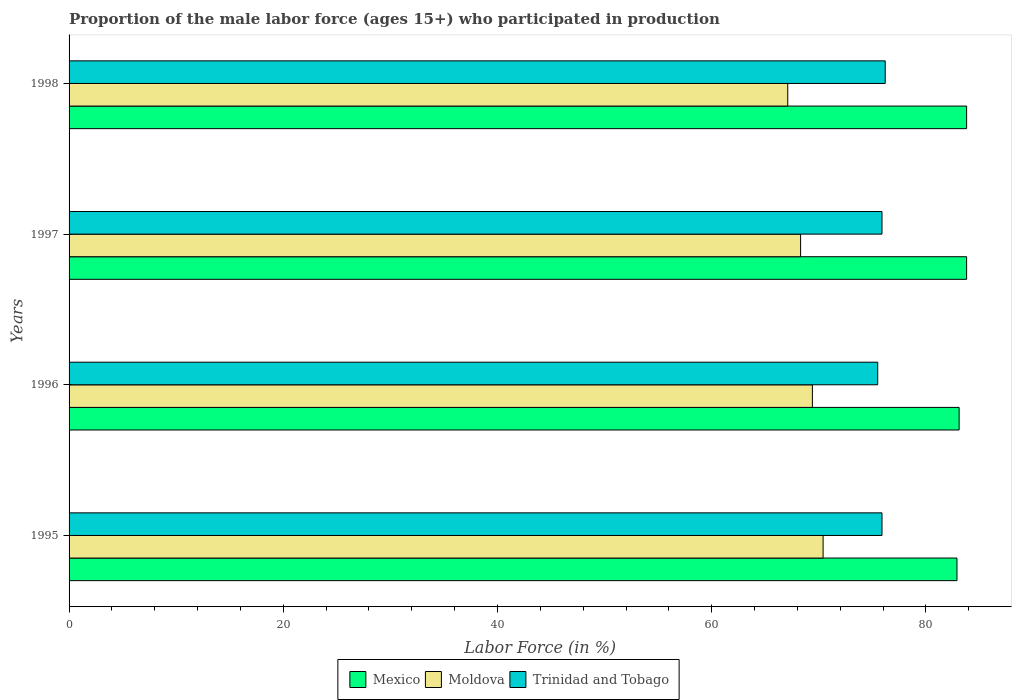How many different coloured bars are there?
Your answer should be compact. 3. Are the number of bars per tick equal to the number of legend labels?
Give a very brief answer. Yes. Are the number of bars on each tick of the Y-axis equal?
Your answer should be compact. Yes. How many bars are there on the 2nd tick from the bottom?
Offer a very short reply. 3. What is the label of the 4th group of bars from the top?
Offer a terse response. 1995. What is the proportion of the male labor force who participated in production in Mexico in 1997?
Give a very brief answer. 83.8. Across all years, what is the maximum proportion of the male labor force who participated in production in Mexico?
Offer a terse response. 83.8. Across all years, what is the minimum proportion of the male labor force who participated in production in Mexico?
Provide a short and direct response. 82.9. In which year was the proportion of the male labor force who participated in production in Moldova maximum?
Provide a short and direct response. 1995. What is the total proportion of the male labor force who participated in production in Mexico in the graph?
Your response must be concise. 333.6. What is the difference between the proportion of the male labor force who participated in production in Moldova in 1997 and that in 1998?
Give a very brief answer. 1.2. What is the difference between the proportion of the male labor force who participated in production in Mexico in 1995 and the proportion of the male labor force who participated in production in Moldova in 1998?
Ensure brevity in your answer.  15.8. What is the average proportion of the male labor force who participated in production in Trinidad and Tobago per year?
Ensure brevity in your answer.  75.88. In the year 1995, what is the difference between the proportion of the male labor force who participated in production in Mexico and proportion of the male labor force who participated in production in Moldova?
Keep it short and to the point. 12.5. In how many years, is the proportion of the male labor force who participated in production in Trinidad and Tobago greater than 64 %?
Give a very brief answer. 4. Is the difference between the proportion of the male labor force who participated in production in Mexico in 1996 and 1998 greater than the difference between the proportion of the male labor force who participated in production in Moldova in 1996 and 1998?
Your response must be concise. No. What is the difference between the highest and the second highest proportion of the male labor force who participated in production in Moldova?
Make the answer very short. 1. What is the difference between the highest and the lowest proportion of the male labor force who participated in production in Moldova?
Your answer should be very brief. 3.3. Is the sum of the proportion of the male labor force who participated in production in Moldova in 1995 and 1998 greater than the maximum proportion of the male labor force who participated in production in Mexico across all years?
Give a very brief answer. Yes. What does the 2nd bar from the top in 1998 represents?
Your answer should be very brief. Moldova. What does the 2nd bar from the bottom in 1998 represents?
Offer a terse response. Moldova. Is it the case that in every year, the sum of the proportion of the male labor force who participated in production in Moldova and proportion of the male labor force who participated in production in Mexico is greater than the proportion of the male labor force who participated in production in Trinidad and Tobago?
Your answer should be very brief. Yes. How many bars are there?
Keep it short and to the point. 12. How many years are there in the graph?
Offer a very short reply. 4. Does the graph contain any zero values?
Your response must be concise. No. Does the graph contain grids?
Offer a terse response. No. How many legend labels are there?
Your answer should be very brief. 3. How are the legend labels stacked?
Keep it short and to the point. Horizontal. What is the title of the graph?
Ensure brevity in your answer.  Proportion of the male labor force (ages 15+) who participated in production. What is the label or title of the Y-axis?
Give a very brief answer. Years. What is the Labor Force (in %) of Mexico in 1995?
Provide a short and direct response. 82.9. What is the Labor Force (in %) in Moldova in 1995?
Provide a succinct answer. 70.4. What is the Labor Force (in %) in Trinidad and Tobago in 1995?
Offer a terse response. 75.9. What is the Labor Force (in %) in Mexico in 1996?
Provide a succinct answer. 83.1. What is the Labor Force (in %) of Moldova in 1996?
Your answer should be compact. 69.4. What is the Labor Force (in %) of Trinidad and Tobago in 1996?
Your response must be concise. 75.5. What is the Labor Force (in %) of Mexico in 1997?
Provide a short and direct response. 83.8. What is the Labor Force (in %) of Moldova in 1997?
Offer a very short reply. 68.3. What is the Labor Force (in %) of Trinidad and Tobago in 1997?
Ensure brevity in your answer.  75.9. What is the Labor Force (in %) of Mexico in 1998?
Give a very brief answer. 83.8. What is the Labor Force (in %) of Moldova in 1998?
Provide a short and direct response. 67.1. What is the Labor Force (in %) in Trinidad and Tobago in 1998?
Provide a short and direct response. 76.2. Across all years, what is the maximum Labor Force (in %) in Mexico?
Your answer should be compact. 83.8. Across all years, what is the maximum Labor Force (in %) in Moldova?
Offer a terse response. 70.4. Across all years, what is the maximum Labor Force (in %) in Trinidad and Tobago?
Your answer should be compact. 76.2. Across all years, what is the minimum Labor Force (in %) of Mexico?
Keep it short and to the point. 82.9. Across all years, what is the minimum Labor Force (in %) in Moldova?
Give a very brief answer. 67.1. Across all years, what is the minimum Labor Force (in %) of Trinidad and Tobago?
Your answer should be very brief. 75.5. What is the total Labor Force (in %) in Mexico in the graph?
Offer a very short reply. 333.6. What is the total Labor Force (in %) of Moldova in the graph?
Your answer should be compact. 275.2. What is the total Labor Force (in %) of Trinidad and Tobago in the graph?
Give a very brief answer. 303.5. What is the difference between the Labor Force (in %) of Mexico in 1995 and that in 1996?
Keep it short and to the point. -0.2. What is the difference between the Labor Force (in %) in Moldova in 1995 and that in 1996?
Your answer should be compact. 1. What is the difference between the Labor Force (in %) of Trinidad and Tobago in 1995 and that in 1997?
Ensure brevity in your answer.  0. What is the difference between the Labor Force (in %) of Mexico in 1995 and that in 1998?
Ensure brevity in your answer.  -0.9. What is the difference between the Labor Force (in %) in Moldova in 1995 and that in 1998?
Keep it short and to the point. 3.3. What is the difference between the Labor Force (in %) of Mexico in 1996 and that in 1998?
Ensure brevity in your answer.  -0.7. What is the difference between the Labor Force (in %) in Moldova in 1995 and the Labor Force (in %) in Trinidad and Tobago in 1996?
Provide a short and direct response. -5.1. What is the difference between the Labor Force (in %) of Mexico in 1995 and the Labor Force (in %) of Moldova in 1997?
Your response must be concise. 14.6. What is the difference between the Labor Force (in %) in Mexico in 1995 and the Labor Force (in %) in Trinidad and Tobago in 1998?
Provide a short and direct response. 6.7. What is the difference between the Labor Force (in %) of Moldova in 1995 and the Labor Force (in %) of Trinidad and Tobago in 1998?
Offer a very short reply. -5.8. What is the difference between the Labor Force (in %) of Mexico in 1996 and the Labor Force (in %) of Moldova in 1997?
Ensure brevity in your answer.  14.8. What is the difference between the Labor Force (in %) of Moldova in 1996 and the Labor Force (in %) of Trinidad and Tobago in 1997?
Your answer should be compact. -6.5. What is the difference between the Labor Force (in %) in Mexico in 1996 and the Labor Force (in %) in Trinidad and Tobago in 1998?
Ensure brevity in your answer.  6.9. What is the difference between the Labor Force (in %) in Mexico in 1997 and the Labor Force (in %) in Moldova in 1998?
Your answer should be very brief. 16.7. What is the difference between the Labor Force (in %) in Mexico in 1997 and the Labor Force (in %) in Trinidad and Tobago in 1998?
Offer a terse response. 7.6. What is the average Labor Force (in %) of Mexico per year?
Make the answer very short. 83.4. What is the average Labor Force (in %) of Moldova per year?
Offer a terse response. 68.8. What is the average Labor Force (in %) of Trinidad and Tobago per year?
Provide a short and direct response. 75.88. In the year 1995, what is the difference between the Labor Force (in %) of Mexico and Labor Force (in %) of Moldova?
Provide a short and direct response. 12.5. In the year 1996, what is the difference between the Labor Force (in %) of Mexico and Labor Force (in %) of Moldova?
Provide a short and direct response. 13.7. In the year 1996, what is the difference between the Labor Force (in %) of Moldova and Labor Force (in %) of Trinidad and Tobago?
Make the answer very short. -6.1. In the year 1997, what is the difference between the Labor Force (in %) of Mexico and Labor Force (in %) of Moldova?
Provide a succinct answer. 15.5. In the year 1997, what is the difference between the Labor Force (in %) of Moldova and Labor Force (in %) of Trinidad and Tobago?
Your answer should be compact. -7.6. In the year 1998, what is the difference between the Labor Force (in %) of Mexico and Labor Force (in %) of Moldova?
Your answer should be compact. 16.7. In the year 1998, what is the difference between the Labor Force (in %) of Mexico and Labor Force (in %) of Trinidad and Tobago?
Keep it short and to the point. 7.6. What is the ratio of the Labor Force (in %) in Mexico in 1995 to that in 1996?
Your answer should be very brief. 1. What is the ratio of the Labor Force (in %) of Moldova in 1995 to that in 1996?
Offer a very short reply. 1.01. What is the ratio of the Labor Force (in %) of Trinidad and Tobago in 1995 to that in 1996?
Your answer should be compact. 1.01. What is the ratio of the Labor Force (in %) of Mexico in 1995 to that in 1997?
Your answer should be compact. 0.99. What is the ratio of the Labor Force (in %) in Moldova in 1995 to that in 1997?
Keep it short and to the point. 1.03. What is the ratio of the Labor Force (in %) in Mexico in 1995 to that in 1998?
Provide a succinct answer. 0.99. What is the ratio of the Labor Force (in %) in Moldova in 1995 to that in 1998?
Provide a short and direct response. 1.05. What is the ratio of the Labor Force (in %) in Moldova in 1996 to that in 1997?
Ensure brevity in your answer.  1.02. What is the ratio of the Labor Force (in %) in Trinidad and Tobago in 1996 to that in 1997?
Offer a terse response. 0.99. What is the ratio of the Labor Force (in %) in Mexico in 1996 to that in 1998?
Offer a terse response. 0.99. What is the ratio of the Labor Force (in %) in Moldova in 1996 to that in 1998?
Ensure brevity in your answer.  1.03. What is the ratio of the Labor Force (in %) in Mexico in 1997 to that in 1998?
Ensure brevity in your answer.  1. What is the ratio of the Labor Force (in %) of Moldova in 1997 to that in 1998?
Give a very brief answer. 1.02. What is the difference between the highest and the second highest Labor Force (in %) in Trinidad and Tobago?
Provide a succinct answer. 0.3. What is the difference between the highest and the lowest Labor Force (in %) of Mexico?
Keep it short and to the point. 0.9. What is the difference between the highest and the lowest Labor Force (in %) in Trinidad and Tobago?
Give a very brief answer. 0.7. 